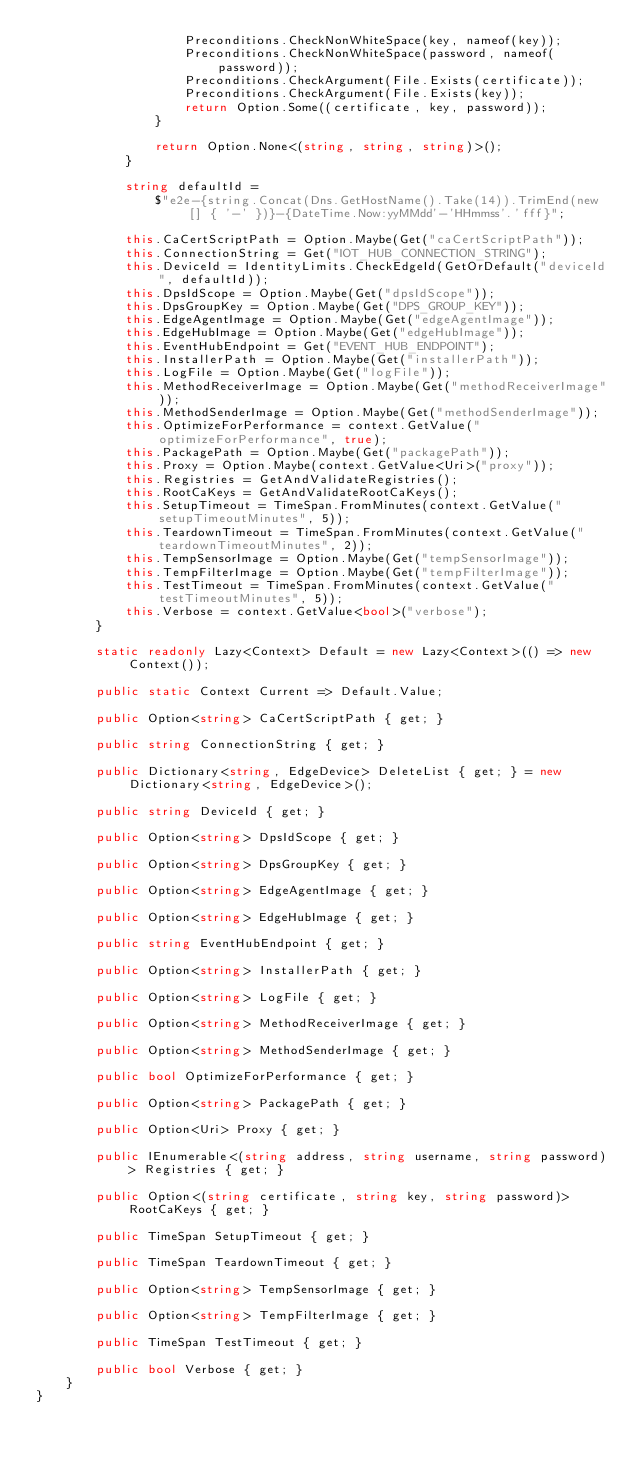<code> <loc_0><loc_0><loc_500><loc_500><_C#_>                    Preconditions.CheckNonWhiteSpace(key, nameof(key));
                    Preconditions.CheckNonWhiteSpace(password, nameof(password));
                    Preconditions.CheckArgument(File.Exists(certificate));
                    Preconditions.CheckArgument(File.Exists(key));
                    return Option.Some((certificate, key, password));
                }

                return Option.None<(string, string, string)>();
            }

            string defaultId =
                $"e2e-{string.Concat(Dns.GetHostName().Take(14)).TrimEnd(new[] { '-' })}-{DateTime.Now:yyMMdd'-'HHmmss'.'fff}";

            this.CaCertScriptPath = Option.Maybe(Get("caCertScriptPath"));
            this.ConnectionString = Get("IOT_HUB_CONNECTION_STRING");
            this.DeviceId = IdentityLimits.CheckEdgeId(GetOrDefault("deviceId", defaultId));
            this.DpsIdScope = Option.Maybe(Get("dpsIdScope"));
            this.DpsGroupKey = Option.Maybe(Get("DPS_GROUP_KEY"));
            this.EdgeAgentImage = Option.Maybe(Get("edgeAgentImage"));
            this.EdgeHubImage = Option.Maybe(Get("edgeHubImage"));
            this.EventHubEndpoint = Get("EVENT_HUB_ENDPOINT");
            this.InstallerPath = Option.Maybe(Get("installerPath"));
            this.LogFile = Option.Maybe(Get("logFile"));
            this.MethodReceiverImage = Option.Maybe(Get("methodReceiverImage"));
            this.MethodSenderImage = Option.Maybe(Get("methodSenderImage"));
            this.OptimizeForPerformance = context.GetValue("optimizeForPerformance", true);
            this.PackagePath = Option.Maybe(Get("packagePath"));
            this.Proxy = Option.Maybe(context.GetValue<Uri>("proxy"));
            this.Registries = GetAndValidateRegistries();
            this.RootCaKeys = GetAndValidateRootCaKeys();
            this.SetupTimeout = TimeSpan.FromMinutes(context.GetValue("setupTimeoutMinutes", 5));
            this.TeardownTimeout = TimeSpan.FromMinutes(context.GetValue("teardownTimeoutMinutes", 2));
            this.TempSensorImage = Option.Maybe(Get("tempSensorImage"));
            this.TempFilterImage = Option.Maybe(Get("tempFilterImage"));
            this.TestTimeout = TimeSpan.FromMinutes(context.GetValue("testTimeoutMinutes", 5));
            this.Verbose = context.GetValue<bool>("verbose");
        }

        static readonly Lazy<Context> Default = new Lazy<Context>(() => new Context());

        public static Context Current => Default.Value;

        public Option<string> CaCertScriptPath { get; }

        public string ConnectionString { get; }

        public Dictionary<string, EdgeDevice> DeleteList { get; } = new Dictionary<string, EdgeDevice>();

        public string DeviceId { get; }

        public Option<string> DpsIdScope { get; }

        public Option<string> DpsGroupKey { get; }

        public Option<string> EdgeAgentImage { get; }

        public Option<string> EdgeHubImage { get; }

        public string EventHubEndpoint { get; }

        public Option<string> InstallerPath { get; }

        public Option<string> LogFile { get; }

        public Option<string> MethodReceiverImage { get; }

        public Option<string> MethodSenderImage { get; }

        public bool OptimizeForPerformance { get; }

        public Option<string> PackagePath { get; }

        public Option<Uri> Proxy { get; }

        public IEnumerable<(string address, string username, string password)> Registries { get; }

        public Option<(string certificate, string key, string password)> RootCaKeys { get; }

        public TimeSpan SetupTimeout { get; }

        public TimeSpan TeardownTimeout { get; }

        public Option<string> TempSensorImage { get; }

        public Option<string> TempFilterImage { get; }

        public TimeSpan TestTimeout { get; }

        public bool Verbose { get; }
    }
}
</code> 